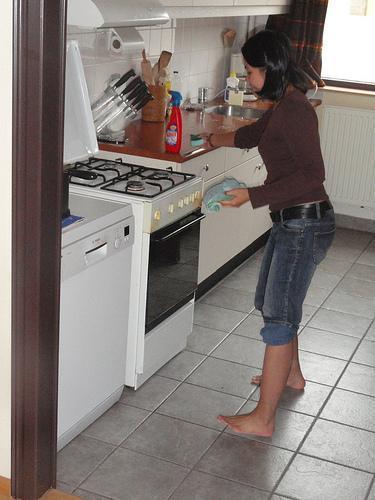How many burners are shown?
Give a very brief answer. 4. 